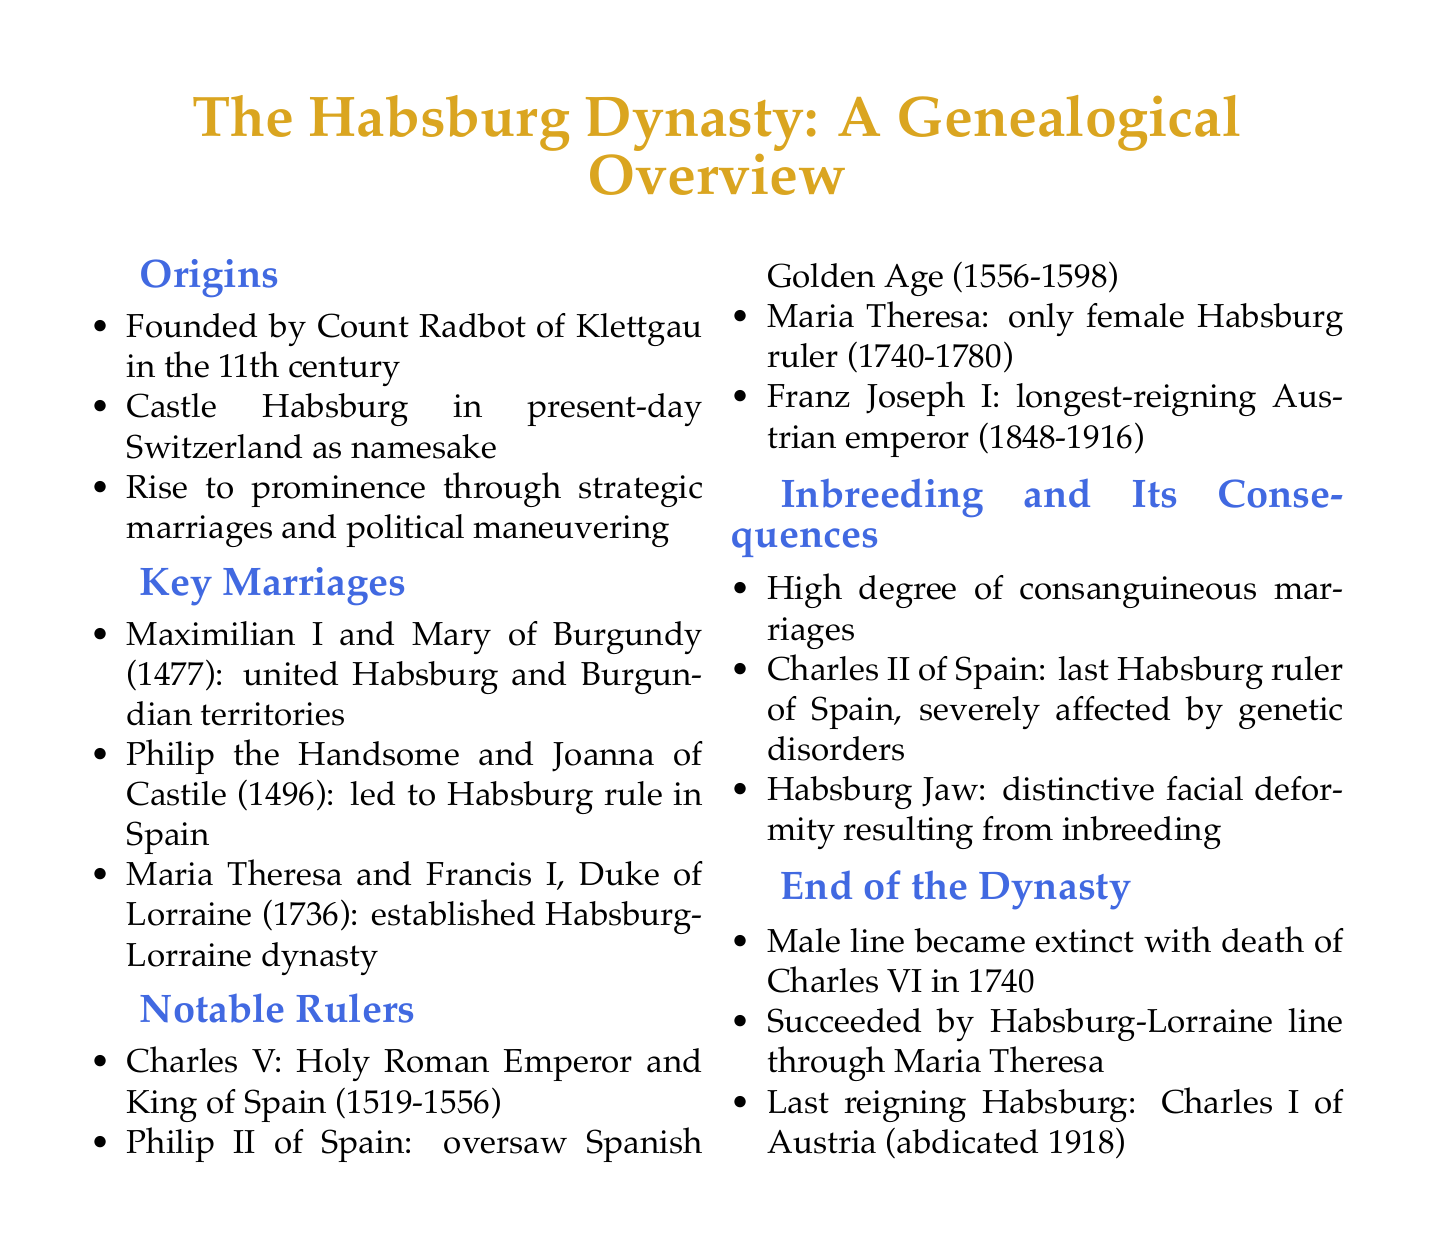What was founded by Count Radbot? Castle Habsburg is the namesake of the dynasty founded by Count Radbot of Klettgau in the 11th century.
Answer: Castle Habsburg In what year did Maximilian I marry Mary of Burgundy? Maximilian I and Mary of Burgundy were married in 1477, uniting Habsburg and Burgundian territories.
Answer: 1477 Who was the last reigning Habsburg? The last reigning Habsburg mentioned in the document is Charles I of Austria, who abdicated in 1918.
Answer: Charles I of Austria What significant issue did Charles II of Spain face? Charles II of Spain was severely affected by genetic disorders due to inbreeding practices within the royal family.
Answer: Genetic disorders What did Maria Theresa establish through her marriage to Francis I? Through her marriage to Francis I, Maria Theresa established the Habsburg-Lorraine dynasty in 1736.
Answer: Habsburg-Lorraine dynasty When did the male line of the Habsburg dynasty become extinct? The male line became extinct with the death of Charles VI in 1740.
Answer: 1740 What distinctive facial deformity is associated with the Habsburg dynasty? The distinctive facial deformity resulting from inbreeding is known as the Habsburg Jaw.
Answer: Habsburg Jaw Which ruler oversaw the Spanish Golden Age? Philip II of Spain oversaw the Spanish Golden Age from 1556 to 1598.
Answer: Philip II of Spain 